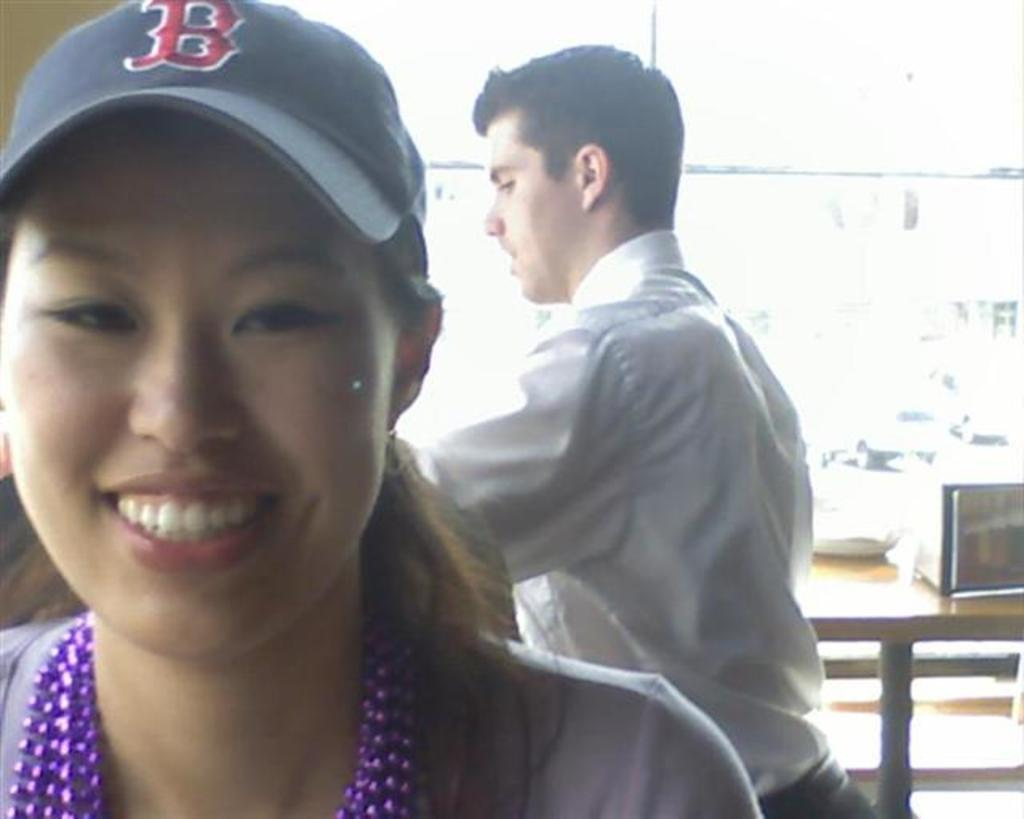<image>
Write a terse but informative summary of the picture. Woman wearing a black hat with a red letter B on it. 